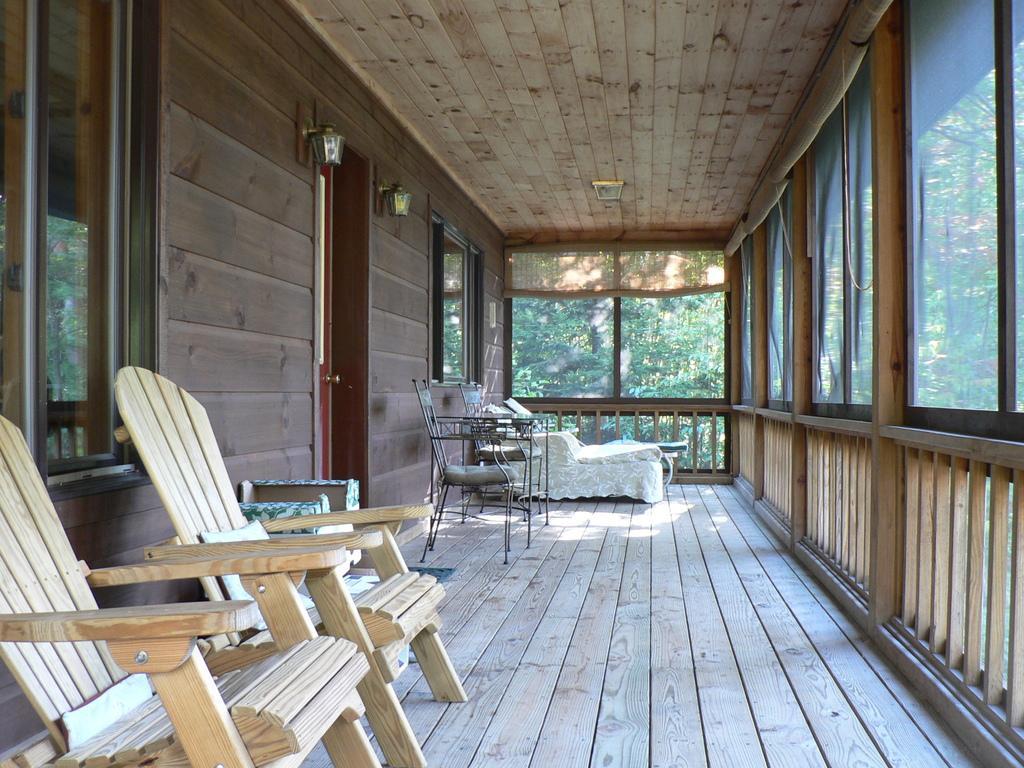Describe this image in one or two sentences. This is a picture taken in a room. In the foreground of the picture there are chairs, window, railing. In the background there are chairs, couch, windows, outside the windows there are trees. It is sunny. 